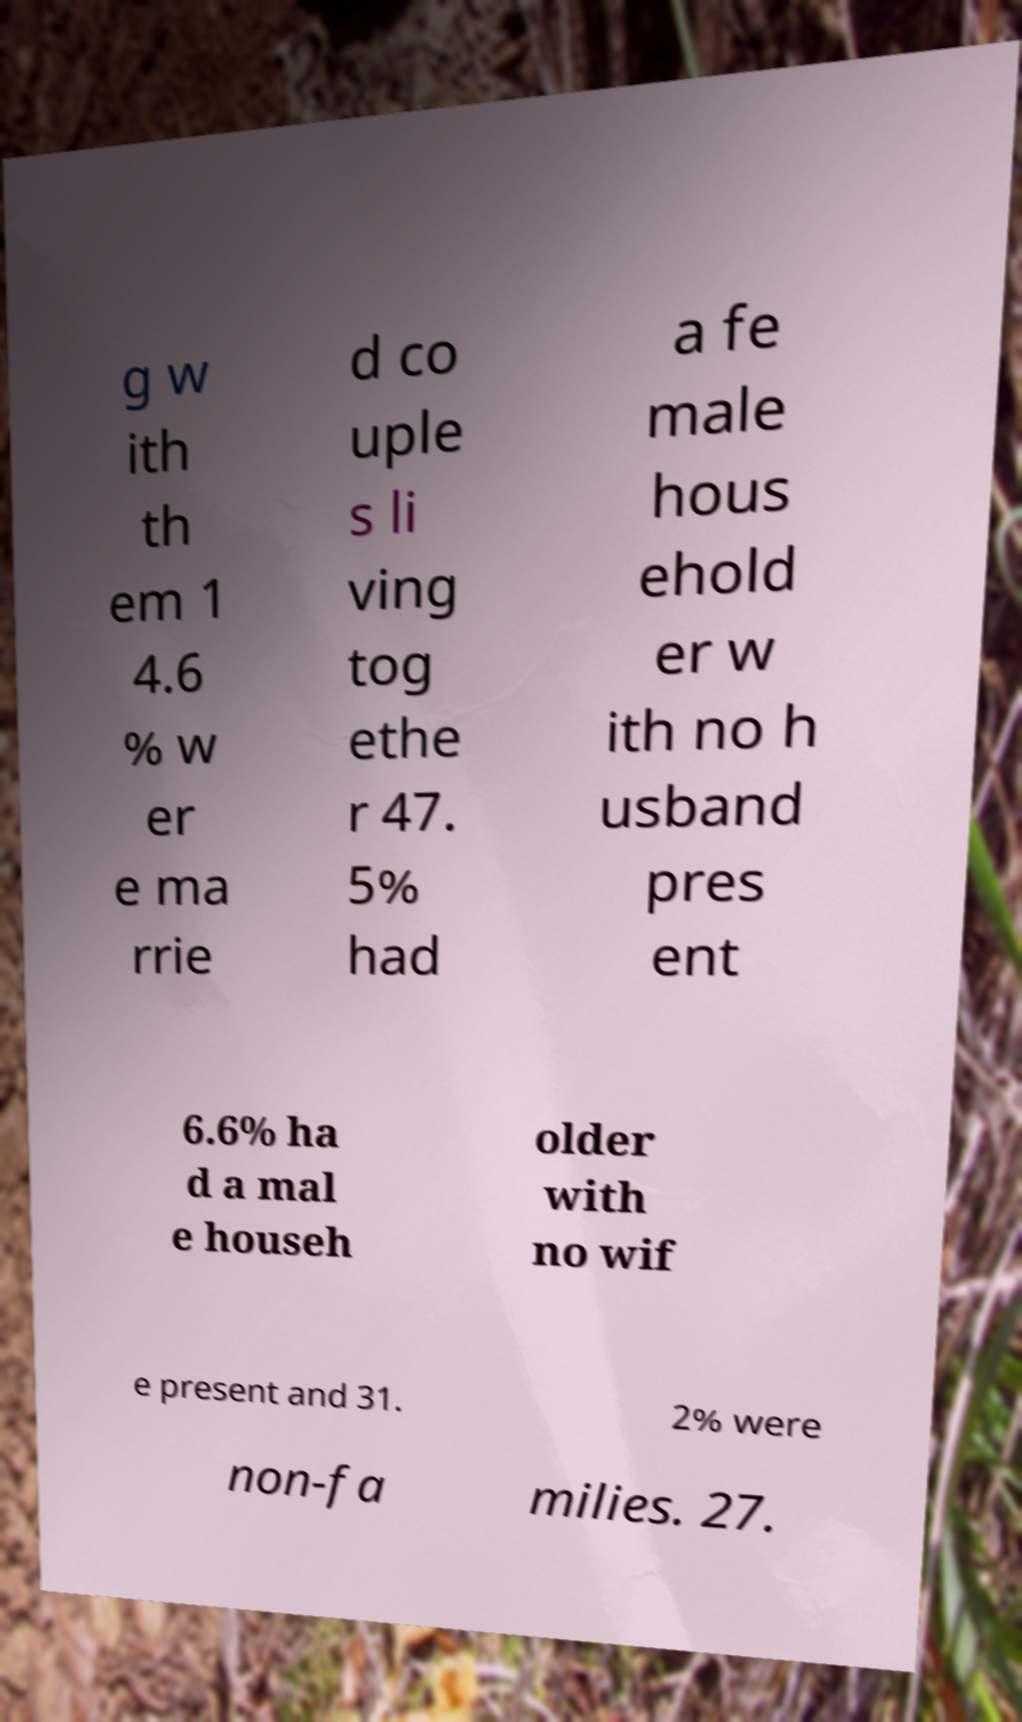Could you extract and type out the text from this image? g w ith th em 1 4.6 % w er e ma rrie d co uple s li ving tog ethe r 47. 5% had a fe male hous ehold er w ith no h usband pres ent 6.6% ha d a mal e househ older with no wif e present and 31. 2% were non-fa milies. 27. 